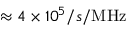<formula> <loc_0><loc_0><loc_500><loc_500>\approx 4 \times 1 0 ^ { 5 } / s / M H z</formula> 